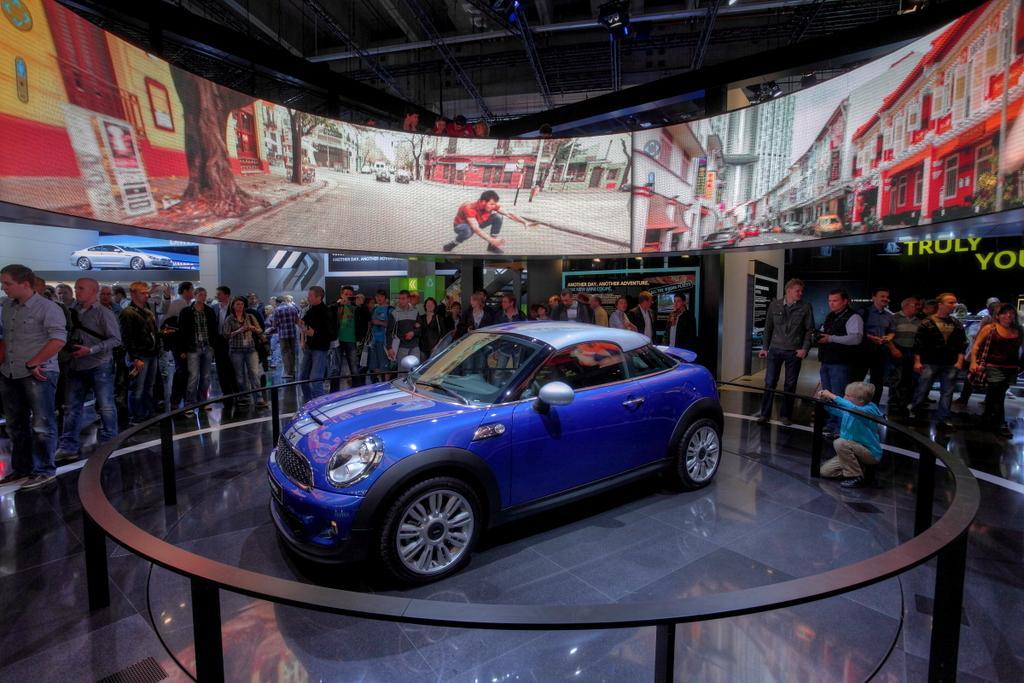Describe this image in one or two sentences. In this image I can see a blue car in the centre and around it I can see few black colour things. In the centre of the image I can see number of people are standing. In the background I can see the depiction pictures of few vehicles, of few buildings, trees and of a man. On the right side of the image I can see something is written. 